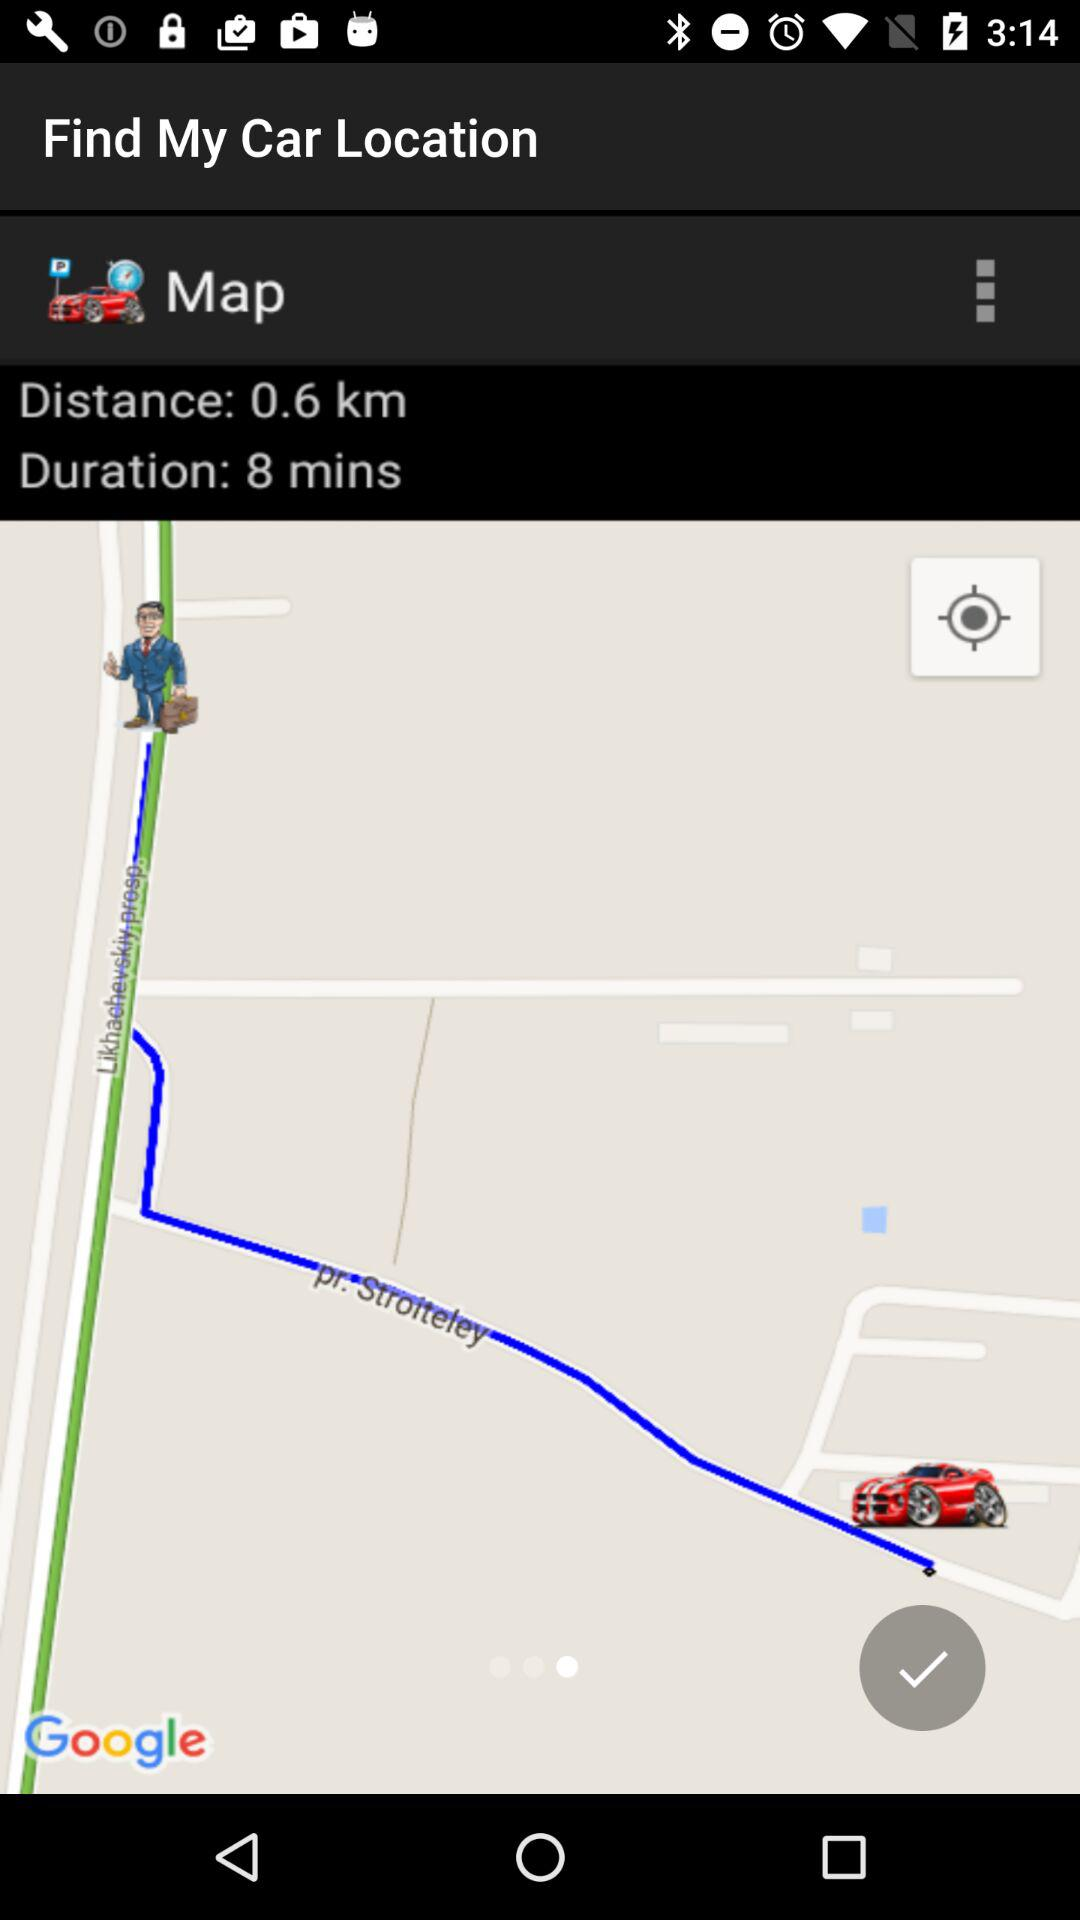How long will it take to get to my car?
Answer the question using a single word or phrase. 8 mins 